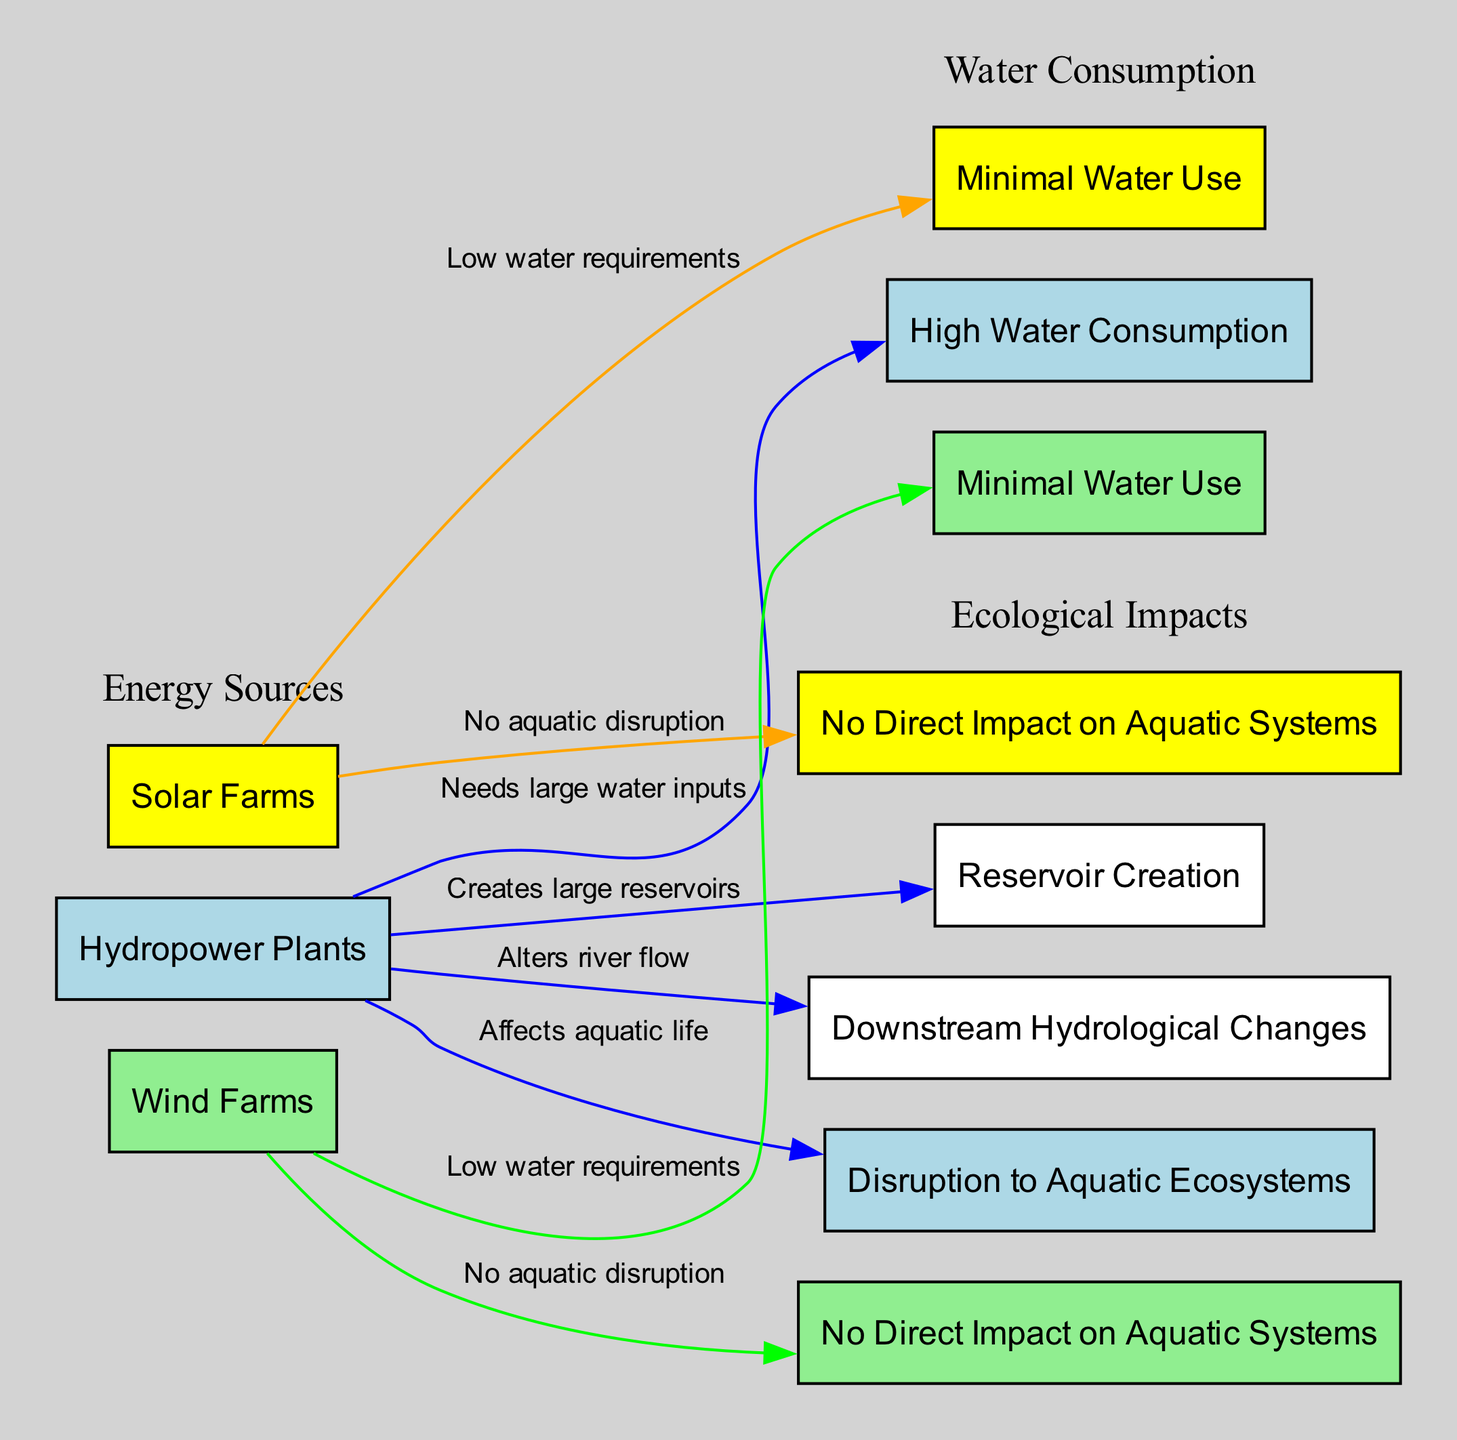What is the water consumption level for hydropower plants? The diagram indicates that hydropower plants have "High Water Consumption." This can be seen through the node connected to "Hydropower Plants" with the description of "Needs large water inputs."
Answer: High Water Consumption How many types of renewable energy sources are compared in this diagram? The diagram features three types of renewable energy sources: hydropower, solar, and wind. Each source is represented as a distinct node grouped together under "Energy Sources."
Answer: Three What is the impact of solar farms on aquatic ecosystems? The diagram illustrates that solar farms have "No Direct Impact on Aquatic Systems." This information is represented in the node that connects solar farms to this specific ecological impact.
Answer: No Direct Impact on Aquatic Systems Which energy source causes significant disruption to aquatic ecosystems? The diagram shows that hydropower plants affect aquatic life, as indicated by the connection from "Hydropower Plants" to "Disruption to Aquatic Ecosystems." This is the only source noted for this negative impact.
Answer: Hydropower Plants List the ecological impacts associated with hydropower plants. According to the diagram, the ecological impacts linked to hydropower plants include "Disruption to Aquatic Ecosystems," "Reservoir Creation," and "Downstream Hydrological Changes." These are represented by three nodes connected to the hydropower plants.
Answer: Disruption to Aquatic Ecosystems, Reservoir Creation, Downstream Hydrological Changes What is a common characteristic of water consumption for both solar and wind farms? The diagram indicates that both solar and wind farms have "Minimal Water Use." This corresponds to the respective nodes connected to each energy source highlighting their low water consumption levels.
Answer: Minimal Water Use How does hydropower affect river flow downstream? The diagram specifies that hydropower plants "Alters river flow," signifying a downstream effect described by the connection from "Hydropower Plants" to "Downstream Hydrological Changes."
Answer: Alters river flow Which renewable energy source has the least water impact? The diagram indicates that both solar and wind farms have "Minimal Water Use," making them the renewable energy sources with the least water impact compared to hydropower plants.
Answer: Solar and Wind Farms What color represents hydropower plants in the diagram? The diagram uses light blue to represent hydropower plants, as indicated by the color coding in the node for "Hydropower Plants."
Answer: Light blue 